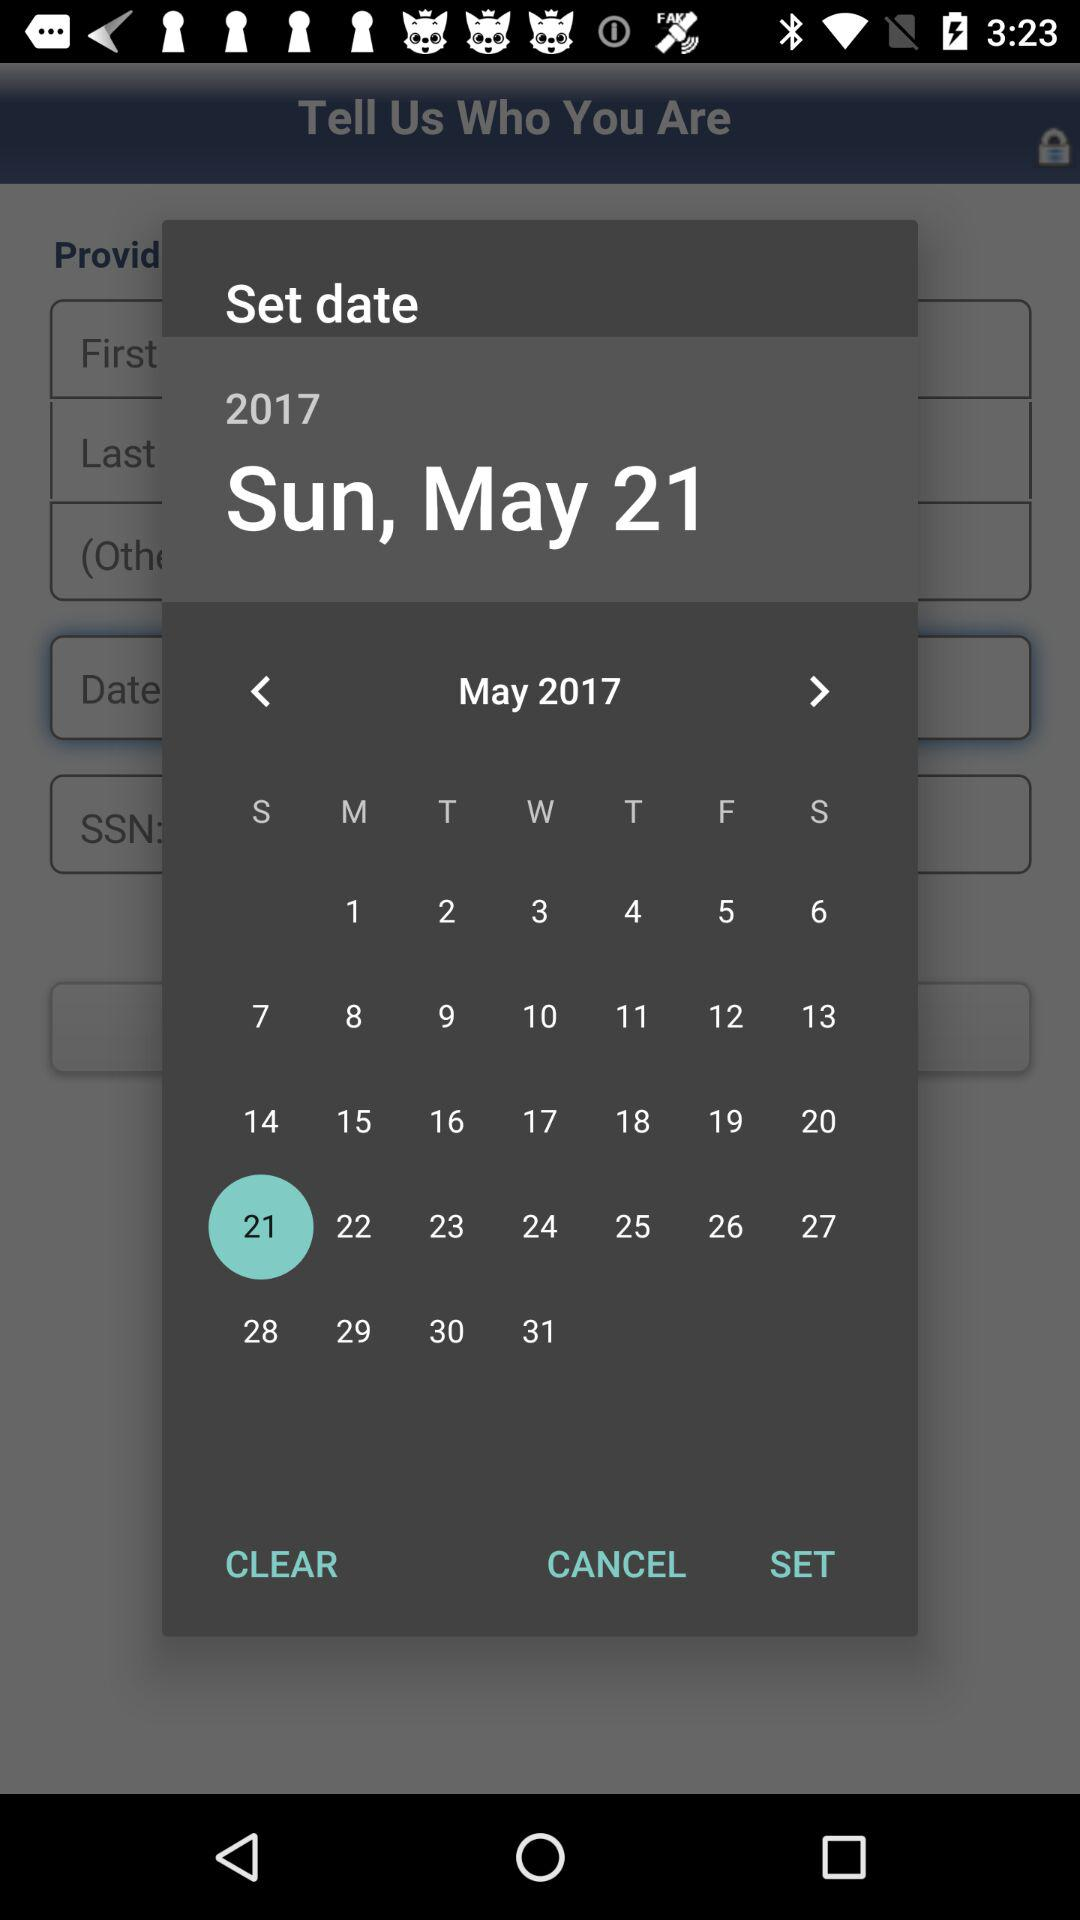What is the set date? The set date is Sunday, May 21, 2017. 